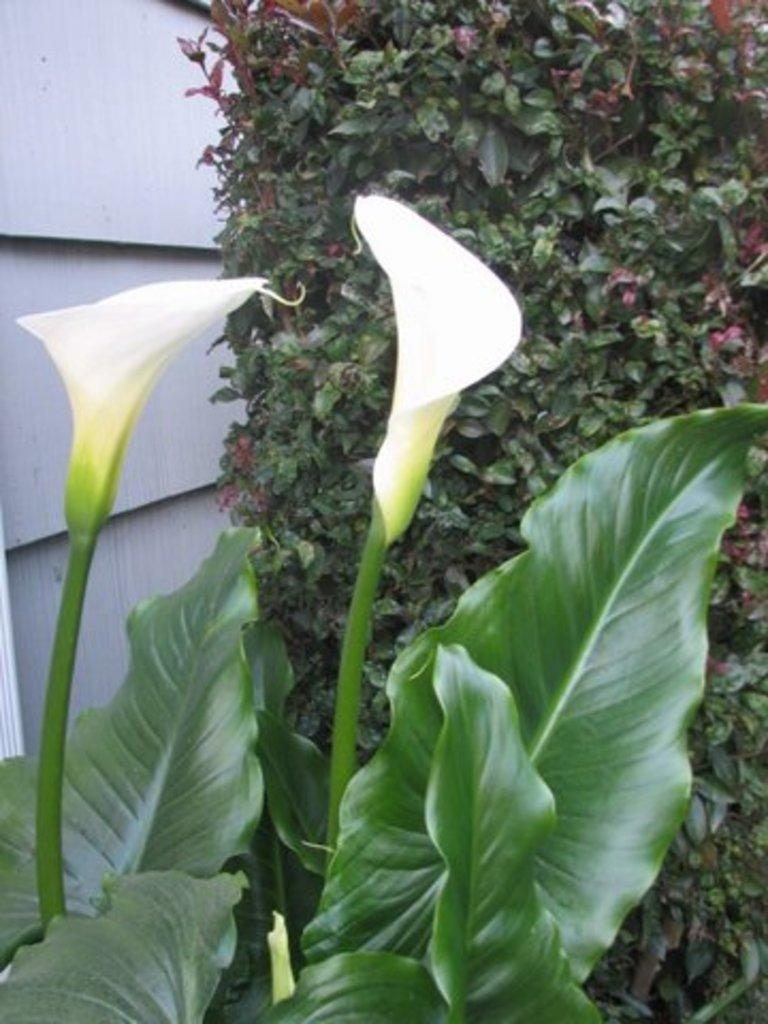What type of living organisms can be seen in the image? Plants can be seen in the image. What specific features can be observed on the plants? There are flowers on the plants. What is the color of the flowers? The flowers are white in color. What type of paste can be seen on the sidewalk in the image? There is no sidewalk or paste present in the image; it features plants with white flowers. 